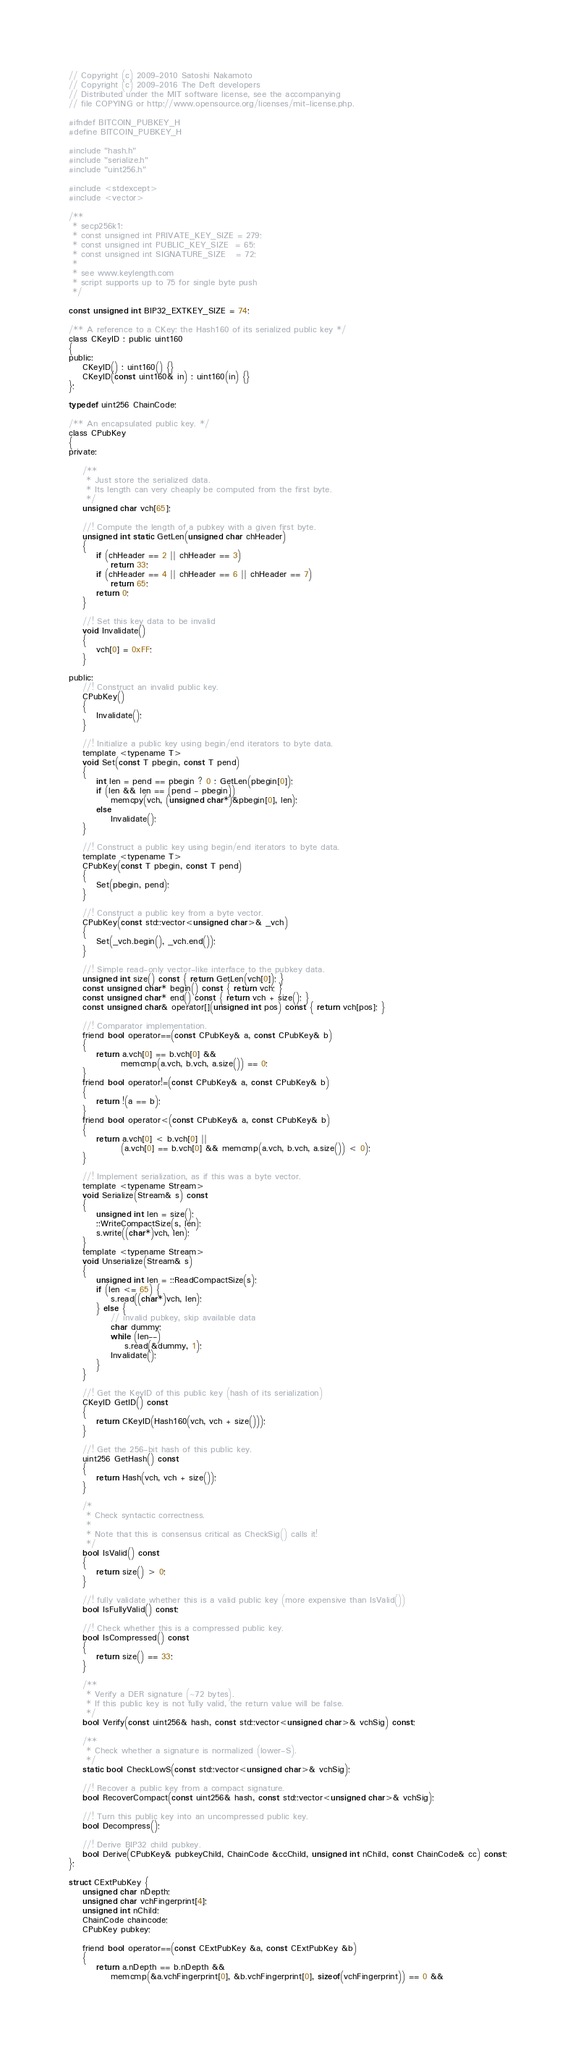Convert code to text. <code><loc_0><loc_0><loc_500><loc_500><_C_>// Copyright (c) 2009-2010 Satoshi Nakamoto
// Copyright (c) 2009-2016 The Deft developers
// Distributed under the MIT software license, see the accompanying
// file COPYING or http://www.opensource.org/licenses/mit-license.php.

#ifndef BITCOIN_PUBKEY_H
#define BITCOIN_PUBKEY_H

#include "hash.h"
#include "serialize.h"
#include "uint256.h"

#include <stdexcept>
#include <vector>

/**
 * secp256k1:
 * const unsigned int PRIVATE_KEY_SIZE = 279;
 * const unsigned int PUBLIC_KEY_SIZE  = 65;
 * const unsigned int SIGNATURE_SIZE   = 72;
 *
 * see www.keylength.com
 * script supports up to 75 for single byte push
 */

const unsigned int BIP32_EXTKEY_SIZE = 74;

/** A reference to a CKey: the Hash160 of its serialized public key */
class CKeyID : public uint160
{
public:
    CKeyID() : uint160() {}
    CKeyID(const uint160& in) : uint160(in) {}
};

typedef uint256 ChainCode;

/** An encapsulated public key. */
class CPubKey
{
private:

    /**
     * Just store the serialized data.
     * Its length can very cheaply be computed from the first byte.
     */
    unsigned char vch[65];

    //! Compute the length of a pubkey with a given first byte.
    unsigned int static GetLen(unsigned char chHeader)
    {
        if (chHeader == 2 || chHeader == 3)
            return 33;
        if (chHeader == 4 || chHeader == 6 || chHeader == 7)
            return 65;
        return 0;
    }

    //! Set this key data to be invalid
    void Invalidate()
    {
        vch[0] = 0xFF;
    }

public:
    //! Construct an invalid public key.
    CPubKey()
    {
        Invalidate();
    }

    //! Initialize a public key using begin/end iterators to byte data.
    template <typename T>
    void Set(const T pbegin, const T pend)
    {
        int len = pend == pbegin ? 0 : GetLen(pbegin[0]);
        if (len && len == (pend - pbegin))
            memcpy(vch, (unsigned char*)&pbegin[0], len);
        else
            Invalidate();
    }

    //! Construct a public key using begin/end iterators to byte data.
    template <typename T>
    CPubKey(const T pbegin, const T pend)
    {
        Set(pbegin, pend);
    }

    //! Construct a public key from a byte vector.
    CPubKey(const std::vector<unsigned char>& _vch)
    {
        Set(_vch.begin(), _vch.end());
    }

    //! Simple read-only vector-like interface to the pubkey data.
    unsigned int size() const { return GetLen(vch[0]); }
    const unsigned char* begin() const { return vch; }
    const unsigned char* end() const { return vch + size(); }
    const unsigned char& operator[](unsigned int pos) const { return vch[pos]; }

    //! Comparator implementation.
    friend bool operator==(const CPubKey& a, const CPubKey& b)
    {
        return a.vch[0] == b.vch[0] &&
               memcmp(a.vch, b.vch, a.size()) == 0;
    }
    friend bool operator!=(const CPubKey& a, const CPubKey& b)
    {
        return !(a == b);
    }
    friend bool operator<(const CPubKey& a, const CPubKey& b)
    {
        return a.vch[0] < b.vch[0] ||
               (a.vch[0] == b.vch[0] && memcmp(a.vch, b.vch, a.size()) < 0);
    }

    //! Implement serialization, as if this was a byte vector.
    template <typename Stream>
    void Serialize(Stream& s) const
    {
        unsigned int len = size();
        ::WriteCompactSize(s, len);
        s.write((char*)vch, len);
    }
    template <typename Stream>
    void Unserialize(Stream& s)
    {
        unsigned int len = ::ReadCompactSize(s);
        if (len <= 65) {
            s.read((char*)vch, len);
        } else {
            // invalid pubkey, skip available data
            char dummy;
            while (len--)
                s.read(&dummy, 1);
            Invalidate();
        }
    }

    //! Get the KeyID of this public key (hash of its serialization)
    CKeyID GetID() const
    {
        return CKeyID(Hash160(vch, vch + size()));
    }

    //! Get the 256-bit hash of this public key.
    uint256 GetHash() const
    {
        return Hash(vch, vch + size());
    }

    /*
     * Check syntactic correctness.
     *
     * Note that this is consensus critical as CheckSig() calls it!
     */
    bool IsValid() const
    {
        return size() > 0;
    }

    //! fully validate whether this is a valid public key (more expensive than IsValid())
    bool IsFullyValid() const;

    //! Check whether this is a compressed public key.
    bool IsCompressed() const
    {
        return size() == 33;
    }

    /**
     * Verify a DER signature (~72 bytes).
     * If this public key is not fully valid, the return value will be false.
     */
    bool Verify(const uint256& hash, const std::vector<unsigned char>& vchSig) const;

    /**
     * Check whether a signature is normalized (lower-S).
     */
    static bool CheckLowS(const std::vector<unsigned char>& vchSig);

    //! Recover a public key from a compact signature.
    bool RecoverCompact(const uint256& hash, const std::vector<unsigned char>& vchSig);

    //! Turn this public key into an uncompressed public key.
    bool Decompress();

    //! Derive BIP32 child pubkey.
    bool Derive(CPubKey& pubkeyChild, ChainCode &ccChild, unsigned int nChild, const ChainCode& cc) const;
};

struct CExtPubKey {
    unsigned char nDepth;
    unsigned char vchFingerprint[4];
    unsigned int nChild;
    ChainCode chaincode;
    CPubKey pubkey;

    friend bool operator==(const CExtPubKey &a, const CExtPubKey &b)
    {
        return a.nDepth == b.nDepth &&
            memcmp(&a.vchFingerprint[0], &b.vchFingerprint[0], sizeof(vchFingerprint)) == 0 &&</code> 